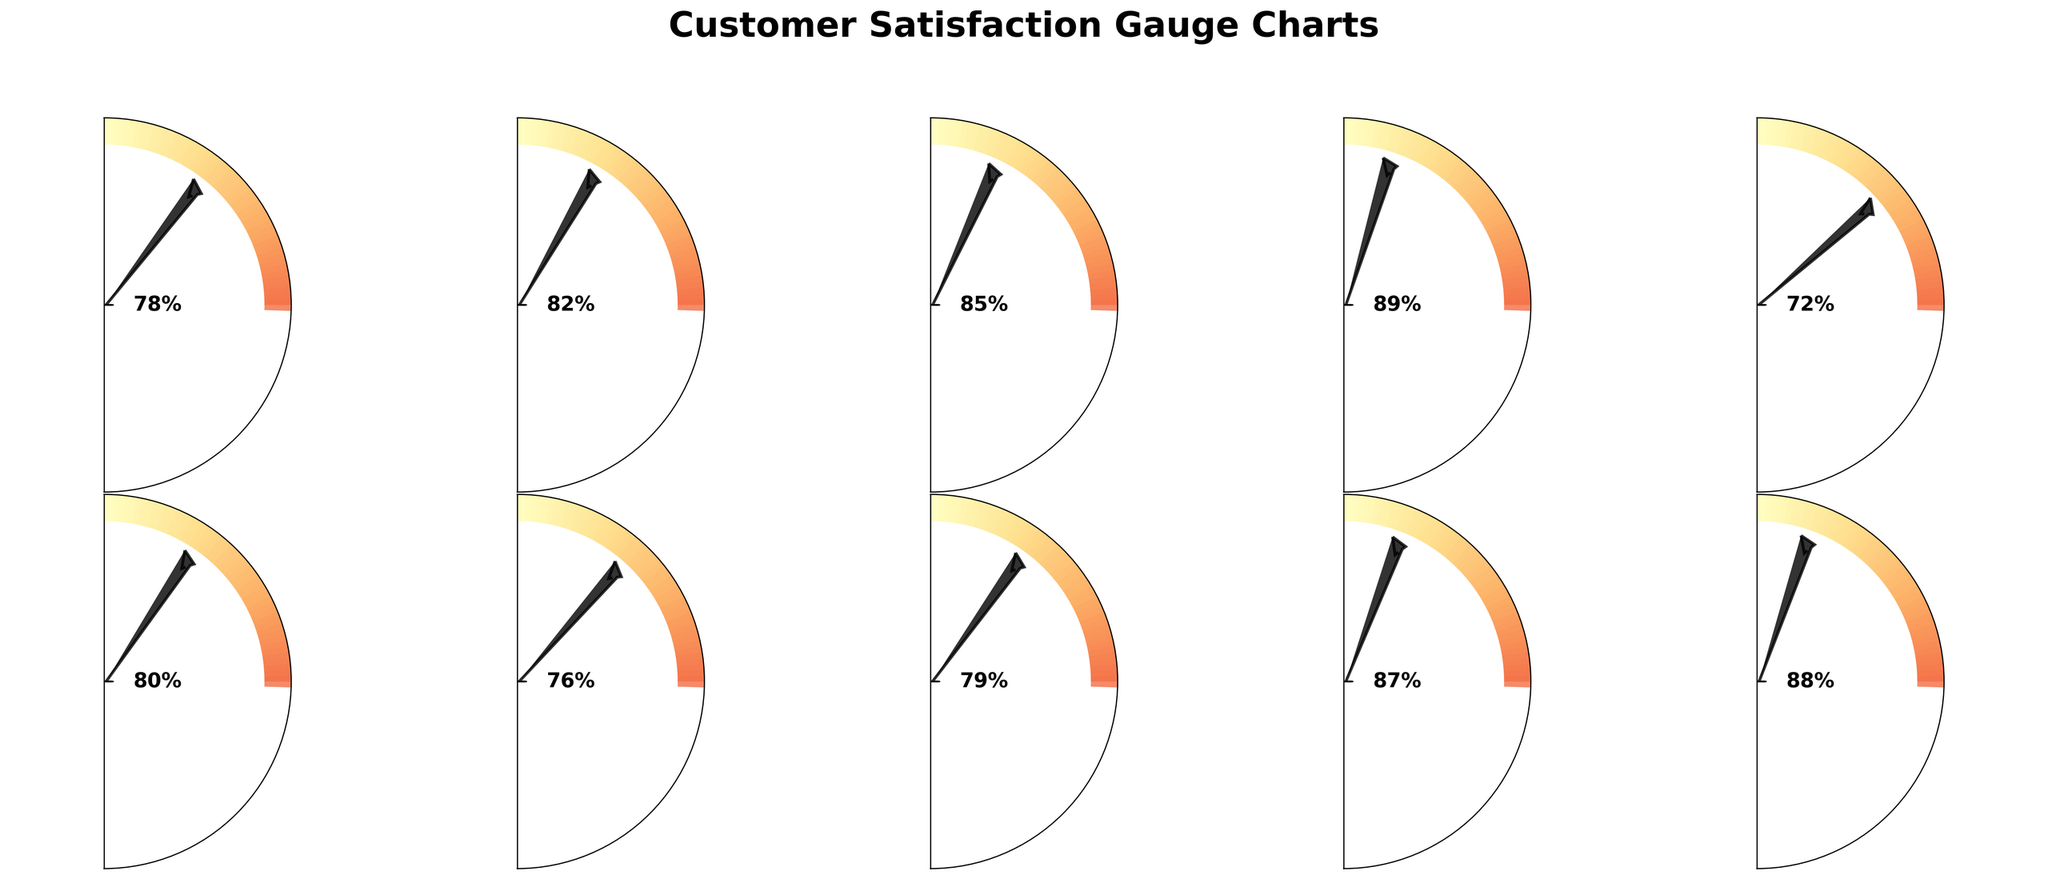Which travel agency has the highest customer satisfaction score? Check all the gauge charts and identify the one with the highest value, which is 89 for Airbnb
Answer: Airbnb Which travel agency has the lowest customer satisfaction score? Look for the gauge chart with the lowest satisfaction score, which is 72 for Thomas Cook
Answer: Thomas Cook What is the average customer satisfaction score of all travel agencies? Add up all the satisfaction scores and divide by the number of travel agencies: (78 + 82 + 85 + 89 + 72 + 80 + 76 + 79 + 87 + 88) / 10 = 81.6
Answer: 81.6 Which travel agencies have a customer satisfaction score higher than 85? Look at the gauge charts and identify the agencies with scores above 85: Airbnb (89), Intrepid Travel (88), G Adventures (87), Booking.com (85)
Answer: Airbnb, Intrepid Travel, G Adventures, Booking.com What's the difference in customer satisfaction score between the highest and lowest rated travel agencies? Subtract the lowest score from the highest score: 89 (Airbnb) - 72 (Thomas Cook) = 17
Answer: 17 How many travel agencies have customer satisfaction scores between 75 and 85? Count the number of gauge charts with scores in that range: Expedia (78), TripAdvisor (82), Booking.com (85), Flight Centre (80), Liberty Travel (76), Travelocity (79) - Total 6
Answer: 6 Which travel agency has its satisfaction needle closest to the center (50%)? Look at the positions of the needles on the gauge charts and find the one with the score closest to 50, which is Thomas Cook at 72
Answer: Thomas Cook Are there more travel agencies with satisfaction scores above or below 80? Count the number of agencies with scores above 80 (5: TripAdvisor, Booking.com, Airbnb, G Adventures, Intrepid Travel) and below 80 (5: Expedia, Thomas Cook, Flight Centre, Liberty Travel, Travelocity)
Answer: Equal Which travel agencies have scores within 5% of each other? Identify agencies with scores that differ by 5 or less: TripAdvisor (82) and Flight Centre (80), G Adventures (87) and Intrepid Travel (88)
Answer: TripAdvisor and Flight Centre, G Adventures and Intrepid Travel 